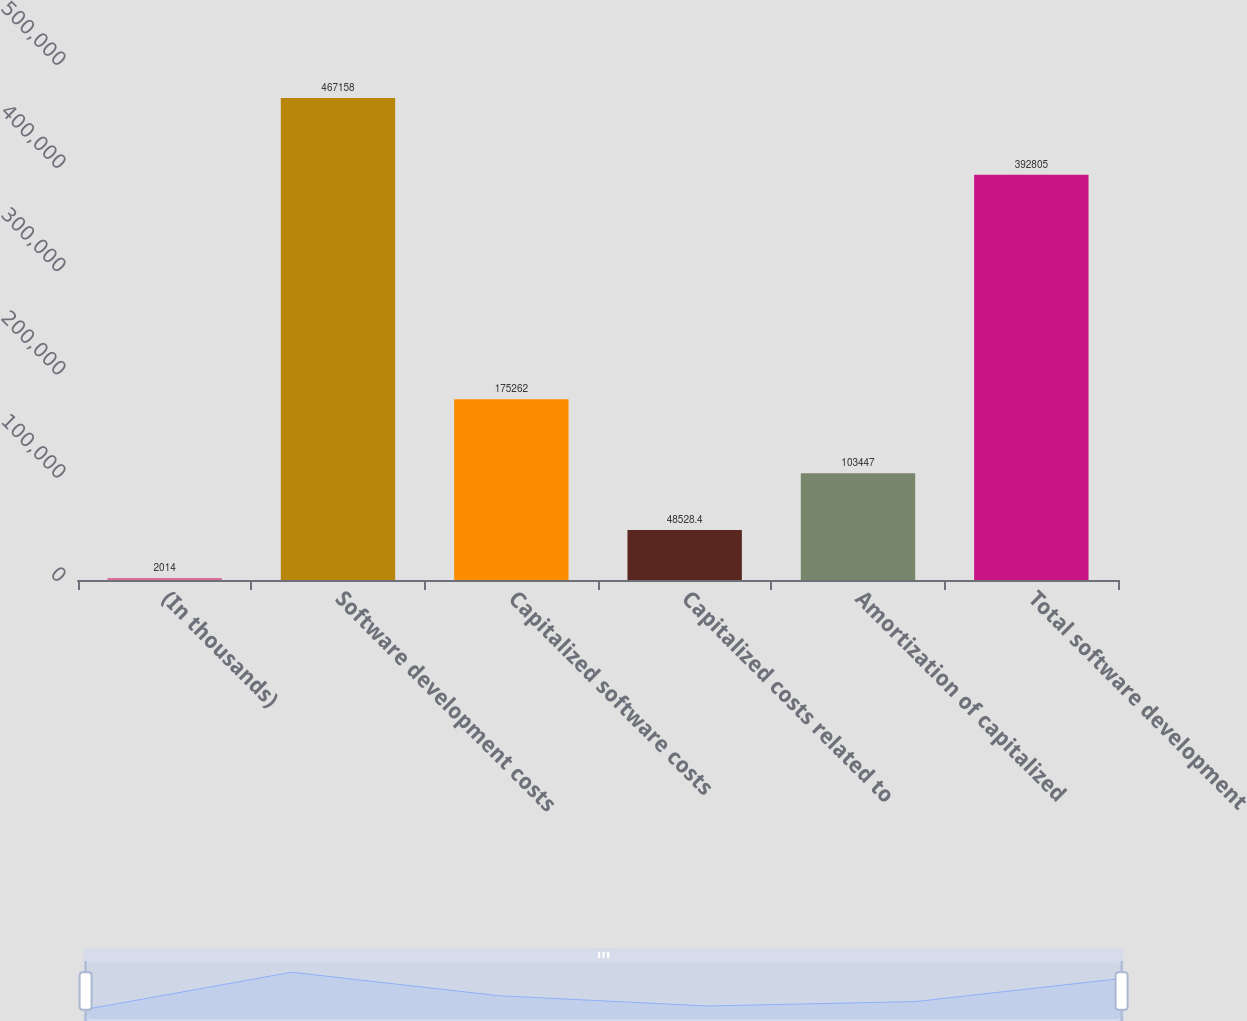Convert chart. <chart><loc_0><loc_0><loc_500><loc_500><bar_chart><fcel>(In thousands)<fcel>Software development costs<fcel>Capitalized software costs<fcel>Capitalized costs related to<fcel>Amortization of capitalized<fcel>Total software development<nl><fcel>2014<fcel>467158<fcel>175262<fcel>48528.4<fcel>103447<fcel>392805<nl></chart> 